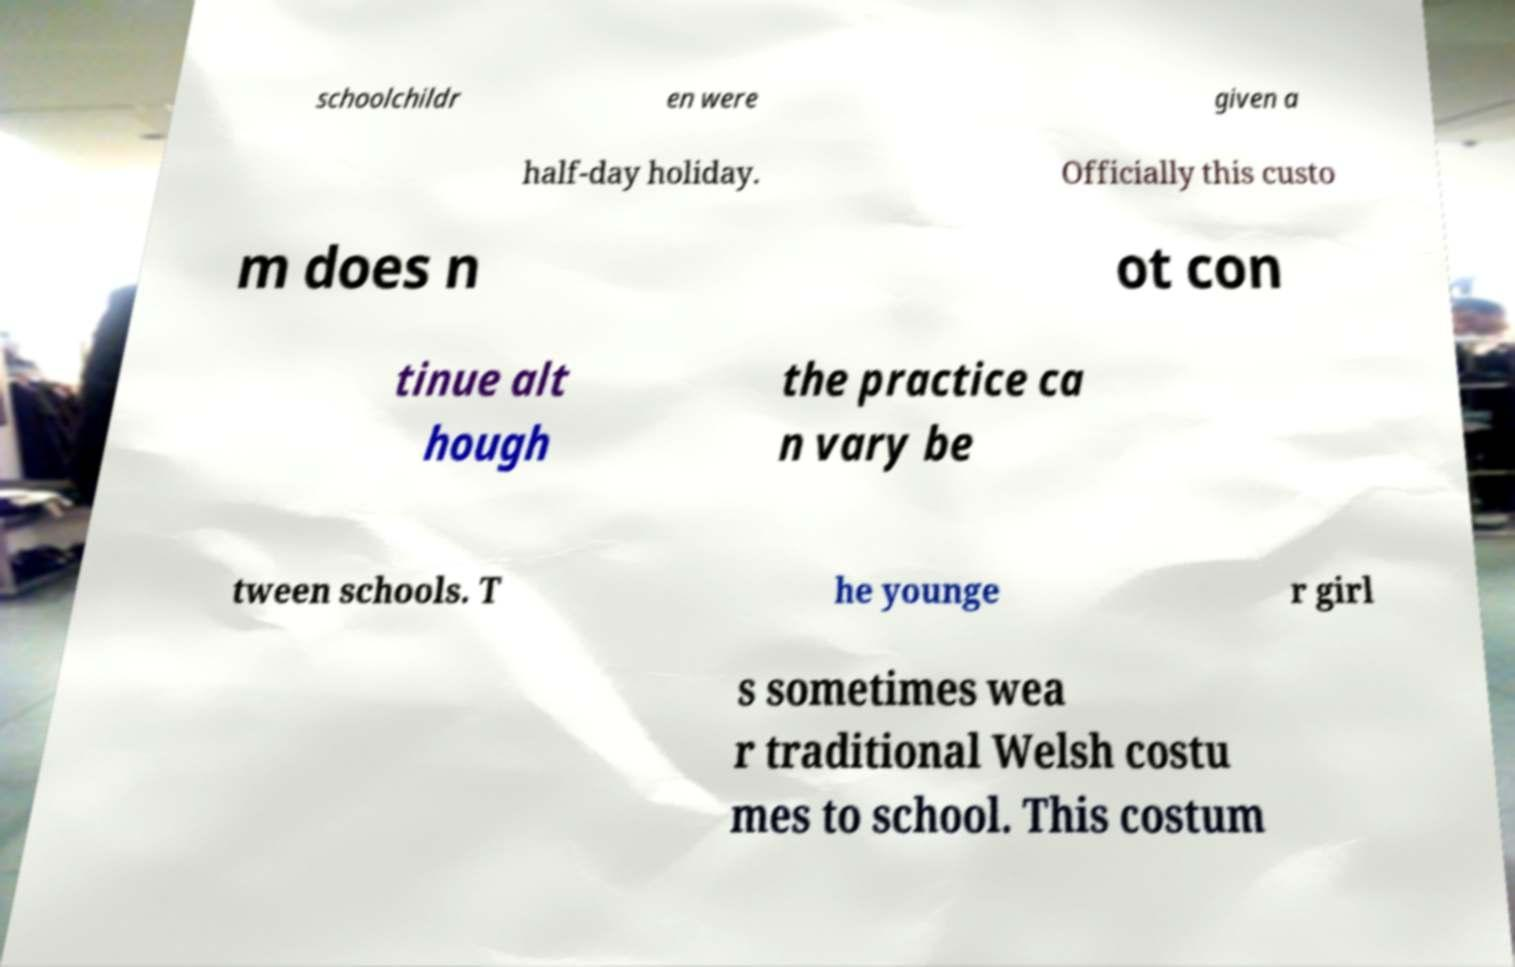Could you extract and type out the text from this image? schoolchildr en were given a half-day holiday. Officially this custo m does n ot con tinue alt hough the practice ca n vary be tween schools. T he younge r girl s sometimes wea r traditional Welsh costu mes to school. This costum 